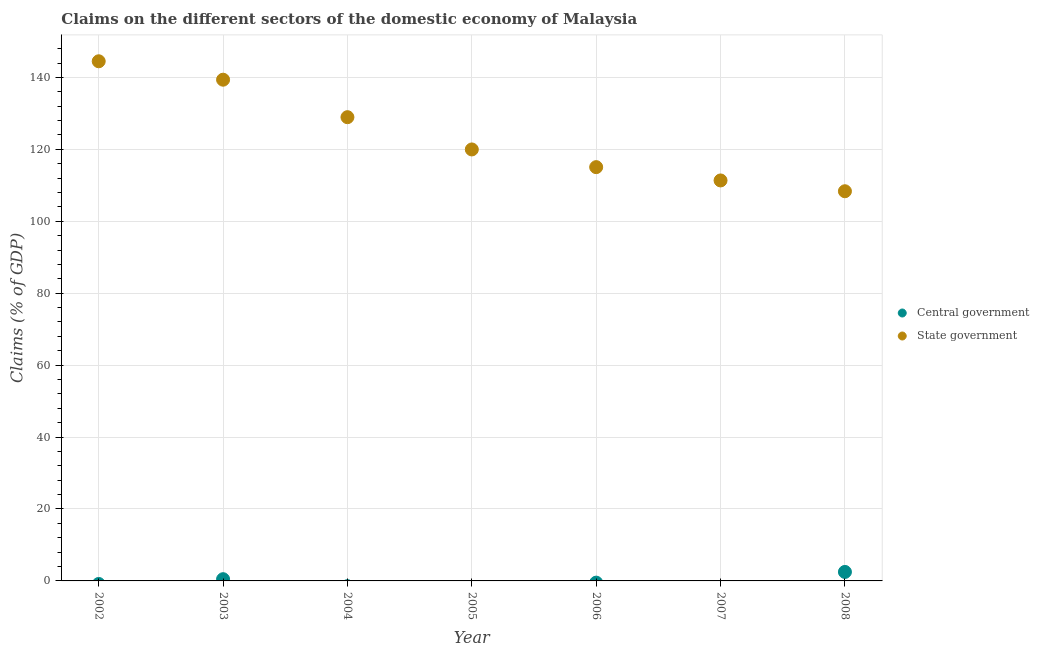What is the claims on state government in 2006?
Your answer should be compact. 115.05. Across all years, what is the maximum claims on state government?
Give a very brief answer. 144.49. Across all years, what is the minimum claims on state government?
Keep it short and to the point. 108.35. In which year was the claims on state government maximum?
Ensure brevity in your answer.  2002. What is the total claims on state government in the graph?
Provide a short and direct response. 867.52. What is the difference between the claims on state government in 2004 and that in 2008?
Your response must be concise. 20.59. What is the difference between the claims on central government in 2002 and the claims on state government in 2005?
Offer a very short reply. -119.97. What is the average claims on central government per year?
Provide a succinct answer. 0.43. In the year 2003, what is the difference between the claims on central government and claims on state government?
Your answer should be very brief. -138.88. What is the ratio of the claims on state government in 2002 to that in 2004?
Offer a terse response. 1.12. What is the difference between the highest and the second highest claims on state government?
Give a very brief answer. 5.12. What is the difference between the highest and the lowest claims on central government?
Offer a very short reply. 2.5. In how many years, is the claims on central government greater than the average claims on central government taken over all years?
Give a very brief answer. 2. Is the claims on central government strictly less than the claims on state government over the years?
Your answer should be compact. Yes. How many dotlines are there?
Your answer should be compact. 2. What is the difference between two consecutive major ticks on the Y-axis?
Your answer should be very brief. 20. Are the values on the major ticks of Y-axis written in scientific E-notation?
Offer a terse response. No. Does the graph contain any zero values?
Your response must be concise. Yes. Where does the legend appear in the graph?
Your answer should be compact. Center right. What is the title of the graph?
Offer a very short reply. Claims on the different sectors of the domestic economy of Malaysia. What is the label or title of the Y-axis?
Make the answer very short. Claims (% of GDP). What is the Claims (% of GDP) in Central government in 2002?
Your answer should be compact. 0. What is the Claims (% of GDP) in State government in 2002?
Provide a short and direct response. 144.49. What is the Claims (% of GDP) of Central government in 2003?
Provide a succinct answer. 0.48. What is the Claims (% of GDP) in State government in 2003?
Provide a short and direct response. 139.37. What is the Claims (% of GDP) in Central government in 2004?
Keep it short and to the point. 0. What is the Claims (% of GDP) in State government in 2004?
Ensure brevity in your answer.  128.94. What is the Claims (% of GDP) in Central government in 2005?
Offer a very short reply. 0. What is the Claims (% of GDP) of State government in 2005?
Provide a short and direct response. 119.97. What is the Claims (% of GDP) of Central government in 2006?
Your answer should be compact. 0. What is the Claims (% of GDP) of State government in 2006?
Provide a succinct answer. 115.05. What is the Claims (% of GDP) of Central government in 2007?
Give a very brief answer. 0. What is the Claims (% of GDP) in State government in 2007?
Make the answer very short. 111.35. What is the Claims (% of GDP) of Central government in 2008?
Your answer should be very brief. 2.5. What is the Claims (% of GDP) of State government in 2008?
Ensure brevity in your answer.  108.35. Across all years, what is the maximum Claims (% of GDP) in Central government?
Your answer should be very brief. 2.5. Across all years, what is the maximum Claims (% of GDP) in State government?
Your answer should be compact. 144.49. Across all years, what is the minimum Claims (% of GDP) of Central government?
Make the answer very short. 0. Across all years, what is the minimum Claims (% of GDP) in State government?
Provide a short and direct response. 108.35. What is the total Claims (% of GDP) in Central government in the graph?
Your answer should be very brief. 2.98. What is the total Claims (% of GDP) in State government in the graph?
Provide a succinct answer. 867.52. What is the difference between the Claims (% of GDP) in State government in 2002 and that in 2003?
Offer a very short reply. 5.12. What is the difference between the Claims (% of GDP) in State government in 2002 and that in 2004?
Ensure brevity in your answer.  15.54. What is the difference between the Claims (% of GDP) in State government in 2002 and that in 2005?
Provide a short and direct response. 24.52. What is the difference between the Claims (% of GDP) in State government in 2002 and that in 2006?
Provide a short and direct response. 29.44. What is the difference between the Claims (% of GDP) of State government in 2002 and that in 2007?
Your response must be concise. 33.13. What is the difference between the Claims (% of GDP) of State government in 2002 and that in 2008?
Ensure brevity in your answer.  36.14. What is the difference between the Claims (% of GDP) of State government in 2003 and that in 2004?
Give a very brief answer. 10.42. What is the difference between the Claims (% of GDP) in State government in 2003 and that in 2005?
Ensure brevity in your answer.  19.39. What is the difference between the Claims (% of GDP) of State government in 2003 and that in 2006?
Your answer should be very brief. 24.31. What is the difference between the Claims (% of GDP) of State government in 2003 and that in 2007?
Your answer should be compact. 28.01. What is the difference between the Claims (% of GDP) of Central government in 2003 and that in 2008?
Provide a succinct answer. -2.02. What is the difference between the Claims (% of GDP) in State government in 2003 and that in 2008?
Give a very brief answer. 31.02. What is the difference between the Claims (% of GDP) of State government in 2004 and that in 2005?
Your response must be concise. 8.97. What is the difference between the Claims (% of GDP) of State government in 2004 and that in 2006?
Your answer should be very brief. 13.89. What is the difference between the Claims (% of GDP) of State government in 2004 and that in 2007?
Your answer should be very brief. 17.59. What is the difference between the Claims (% of GDP) of State government in 2004 and that in 2008?
Your answer should be compact. 20.59. What is the difference between the Claims (% of GDP) of State government in 2005 and that in 2006?
Make the answer very short. 4.92. What is the difference between the Claims (% of GDP) in State government in 2005 and that in 2007?
Provide a succinct answer. 8.62. What is the difference between the Claims (% of GDP) of State government in 2005 and that in 2008?
Give a very brief answer. 11.62. What is the difference between the Claims (% of GDP) in State government in 2006 and that in 2007?
Your response must be concise. 3.7. What is the difference between the Claims (% of GDP) of State government in 2006 and that in 2008?
Your answer should be compact. 6.7. What is the difference between the Claims (% of GDP) of State government in 2007 and that in 2008?
Keep it short and to the point. 3. What is the difference between the Claims (% of GDP) of Central government in 2003 and the Claims (% of GDP) of State government in 2004?
Offer a very short reply. -128.46. What is the difference between the Claims (% of GDP) of Central government in 2003 and the Claims (% of GDP) of State government in 2005?
Offer a very short reply. -119.49. What is the difference between the Claims (% of GDP) of Central government in 2003 and the Claims (% of GDP) of State government in 2006?
Ensure brevity in your answer.  -114.57. What is the difference between the Claims (% of GDP) in Central government in 2003 and the Claims (% of GDP) in State government in 2007?
Ensure brevity in your answer.  -110.87. What is the difference between the Claims (% of GDP) of Central government in 2003 and the Claims (% of GDP) of State government in 2008?
Keep it short and to the point. -107.87. What is the average Claims (% of GDP) of Central government per year?
Your response must be concise. 0.43. What is the average Claims (% of GDP) in State government per year?
Provide a succinct answer. 123.93. In the year 2003, what is the difference between the Claims (% of GDP) in Central government and Claims (% of GDP) in State government?
Provide a succinct answer. -138.88. In the year 2008, what is the difference between the Claims (% of GDP) in Central government and Claims (% of GDP) in State government?
Your answer should be very brief. -105.85. What is the ratio of the Claims (% of GDP) of State government in 2002 to that in 2003?
Your response must be concise. 1.04. What is the ratio of the Claims (% of GDP) in State government in 2002 to that in 2004?
Your answer should be very brief. 1.12. What is the ratio of the Claims (% of GDP) of State government in 2002 to that in 2005?
Ensure brevity in your answer.  1.2. What is the ratio of the Claims (% of GDP) of State government in 2002 to that in 2006?
Ensure brevity in your answer.  1.26. What is the ratio of the Claims (% of GDP) of State government in 2002 to that in 2007?
Provide a succinct answer. 1.3. What is the ratio of the Claims (% of GDP) of State government in 2002 to that in 2008?
Provide a short and direct response. 1.33. What is the ratio of the Claims (% of GDP) of State government in 2003 to that in 2004?
Your answer should be very brief. 1.08. What is the ratio of the Claims (% of GDP) of State government in 2003 to that in 2005?
Your answer should be very brief. 1.16. What is the ratio of the Claims (% of GDP) in State government in 2003 to that in 2006?
Provide a succinct answer. 1.21. What is the ratio of the Claims (% of GDP) of State government in 2003 to that in 2007?
Offer a very short reply. 1.25. What is the ratio of the Claims (% of GDP) of Central government in 2003 to that in 2008?
Give a very brief answer. 0.19. What is the ratio of the Claims (% of GDP) of State government in 2003 to that in 2008?
Give a very brief answer. 1.29. What is the ratio of the Claims (% of GDP) in State government in 2004 to that in 2005?
Your answer should be compact. 1.07. What is the ratio of the Claims (% of GDP) of State government in 2004 to that in 2006?
Offer a terse response. 1.12. What is the ratio of the Claims (% of GDP) in State government in 2004 to that in 2007?
Your answer should be compact. 1.16. What is the ratio of the Claims (% of GDP) of State government in 2004 to that in 2008?
Make the answer very short. 1.19. What is the ratio of the Claims (% of GDP) of State government in 2005 to that in 2006?
Ensure brevity in your answer.  1.04. What is the ratio of the Claims (% of GDP) in State government in 2005 to that in 2007?
Give a very brief answer. 1.08. What is the ratio of the Claims (% of GDP) in State government in 2005 to that in 2008?
Your answer should be very brief. 1.11. What is the ratio of the Claims (% of GDP) of State government in 2006 to that in 2007?
Make the answer very short. 1.03. What is the ratio of the Claims (% of GDP) in State government in 2006 to that in 2008?
Keep it short and to the point. 1.06. What is the ratio of the Claims (% of GDP) in State government in 2007 to that in 2008?
Give a very brief answer. 1.03. What is the difference between the highest and the second highest Claims (% of GDP) of State government?
Give a very brief answer. 5.12. What is the difference between the highest and the lowest Claims (% of GDP) of Central government?
Offer a terse response. 2.5. What is the difference between the highest and the lowest Claims (% of GDP) of State government?
Ensure brevity in your answer.  36.14. 